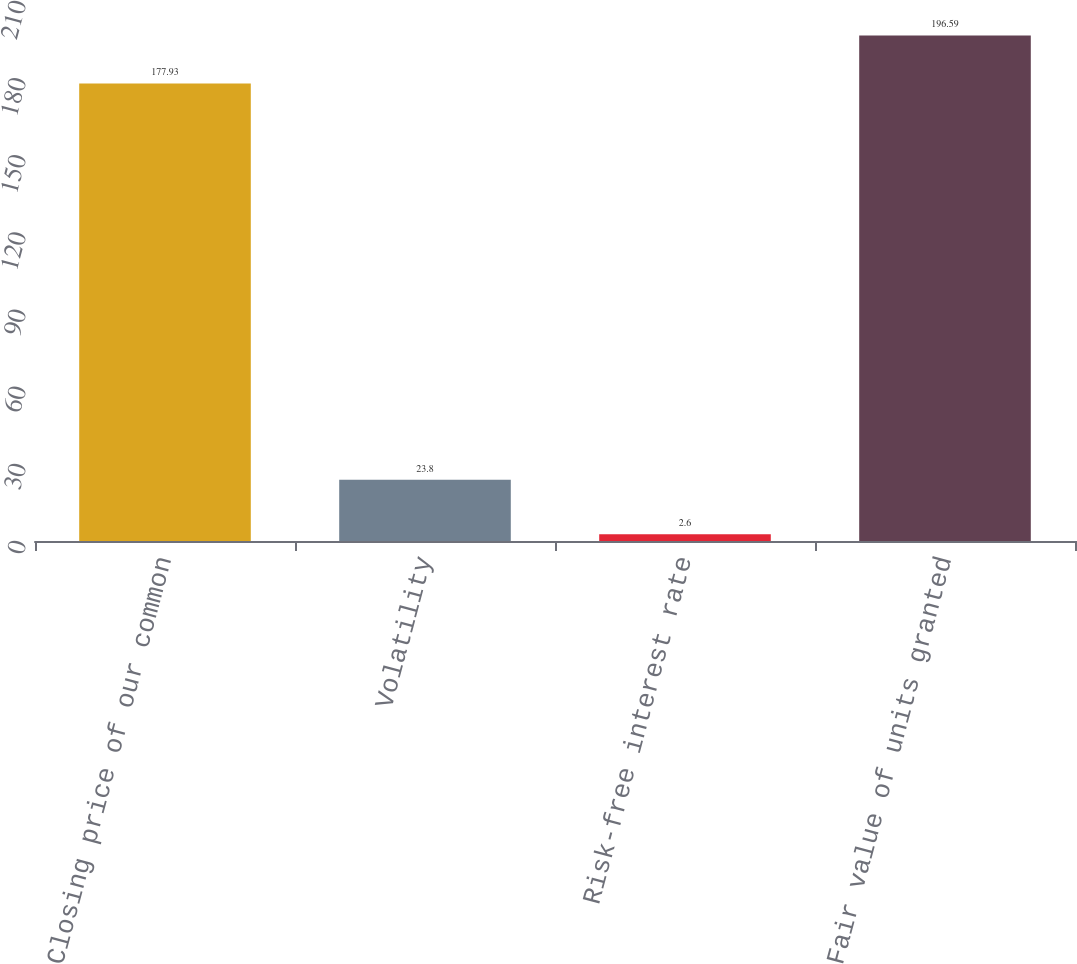Convert chart to OTSL. <chart><loc_0><loc_0><loc_500><loc_500><bar_chart><fcel>Closing price of our common<fcel>Volatility<fcel>Risk-free interest rate<fcel>Fair value of units granted<nl><fcel>177.93<fcel>23.8<fcel>2.6<fcel>196.59<nl></chart> 